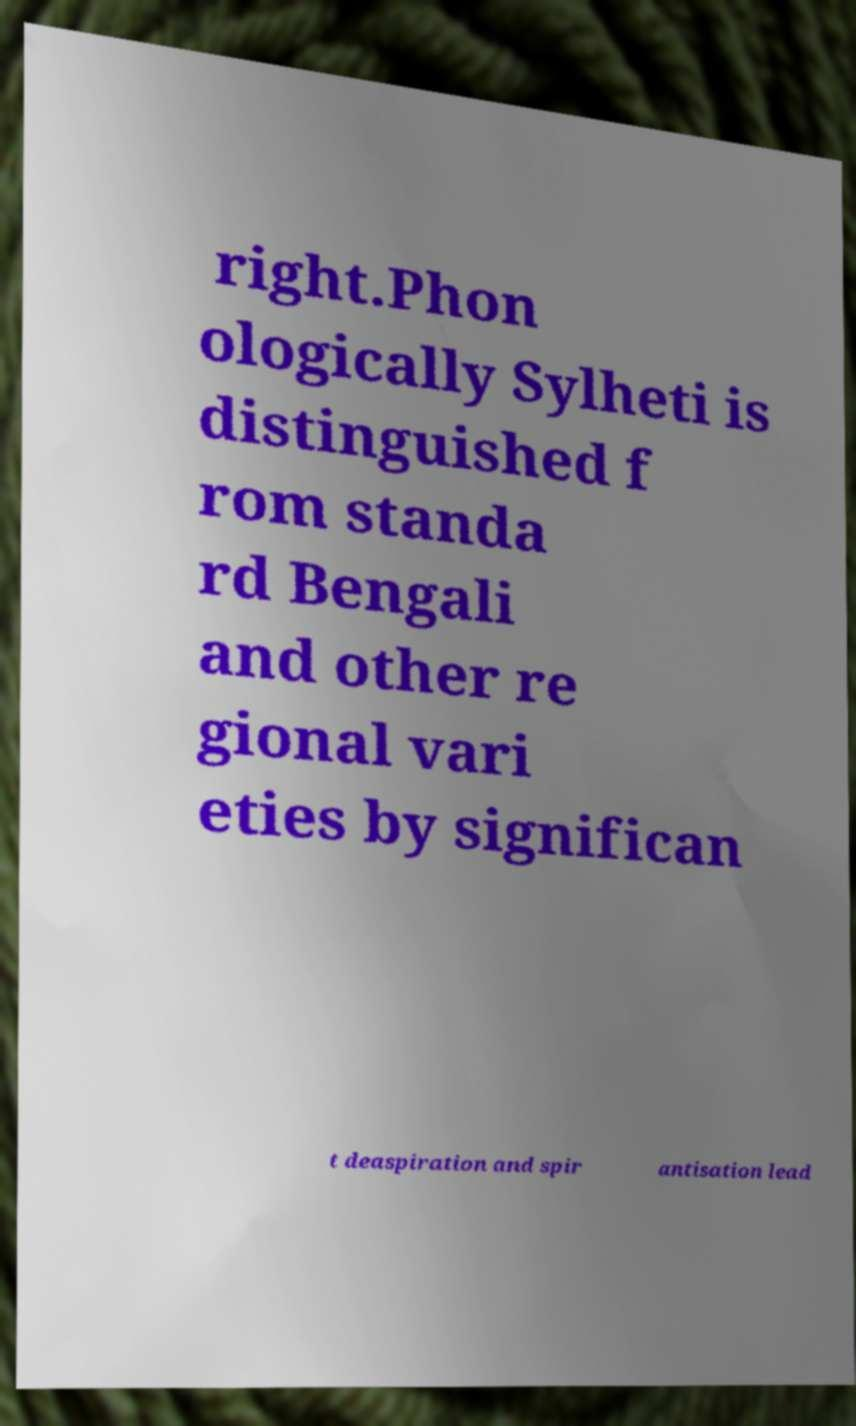Please read and relay the text visible in this image. What does it say? right.Phon ologically Sylheti is distinguished f rom standa rd Bengali and other re gional vari eties by significan t deaspiration and spir antisation lead 